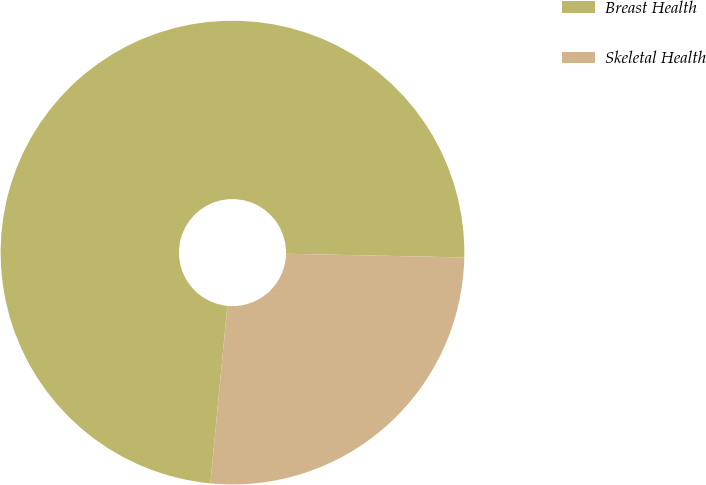Convert chart. <chart><loc_0><loc_0><loc_500><loc_500><pie_chart><fcel>Breast Health<fcel>Skeletal Health<nl><fcel>73.81%<fcel>26.19%<nl></chart> 